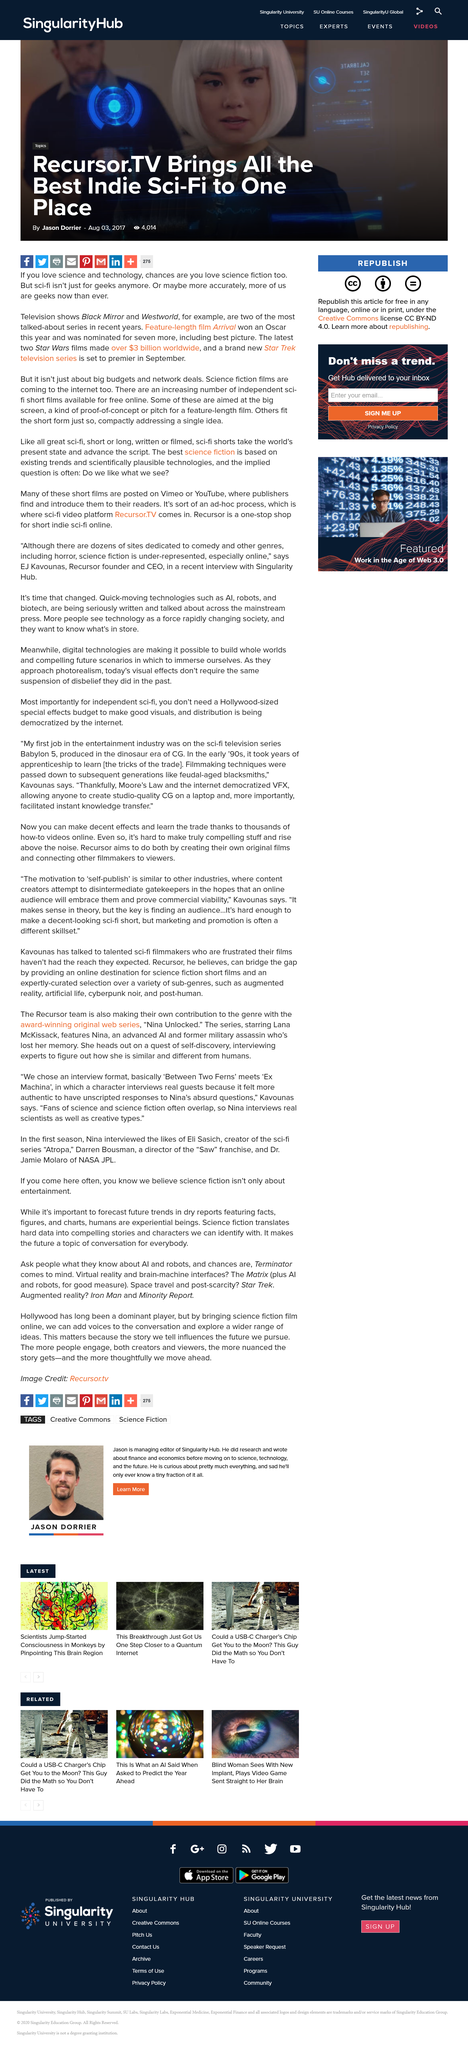Outline some significant characteristics in this image. The brand new Star Trek television series will premiere in September. The latest two Star Wars films have collectively grossed over $3 billion in worldwide box office revenue. The film that won an Oscar this year and was nominated for Best Picture is "Arrival. 